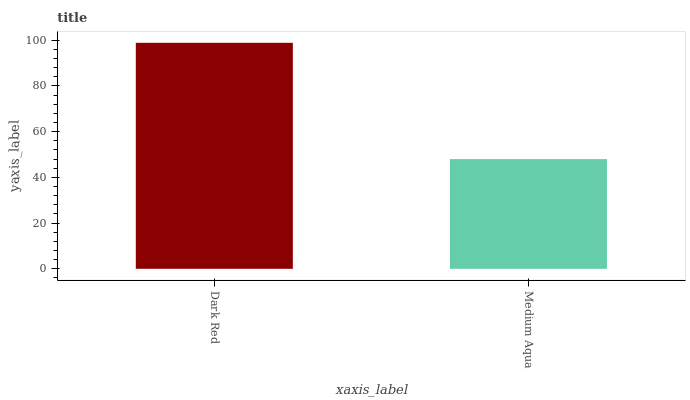Is Medium Aqua the minimum?
Answer yes or no. Yes. Is Dark Red the maximum?
Answer yes or no. Yes. Is Medium Aqua the maximum?
Answer yes or no. No. Is Dark Red greater than Medium Aqua?
Answer yes or no. Yes. Is Medium Aqua less than Dark Red?
Answer yes or no. Yes. Is Medium Aqua greater than Dark Red?
Answer yes or no. No. Is Dark Red less than Medium Aqua?
Answer yes or no. No. Is Dark Red the high median?
Answer yes or no. Yes. Is Medium Aqua the low median?
Answer yes or no. Yes. Is Medium Aqua the high median?
Answer yes or no. No. Is Dark Red the low median?
Answer yes or no. No. 